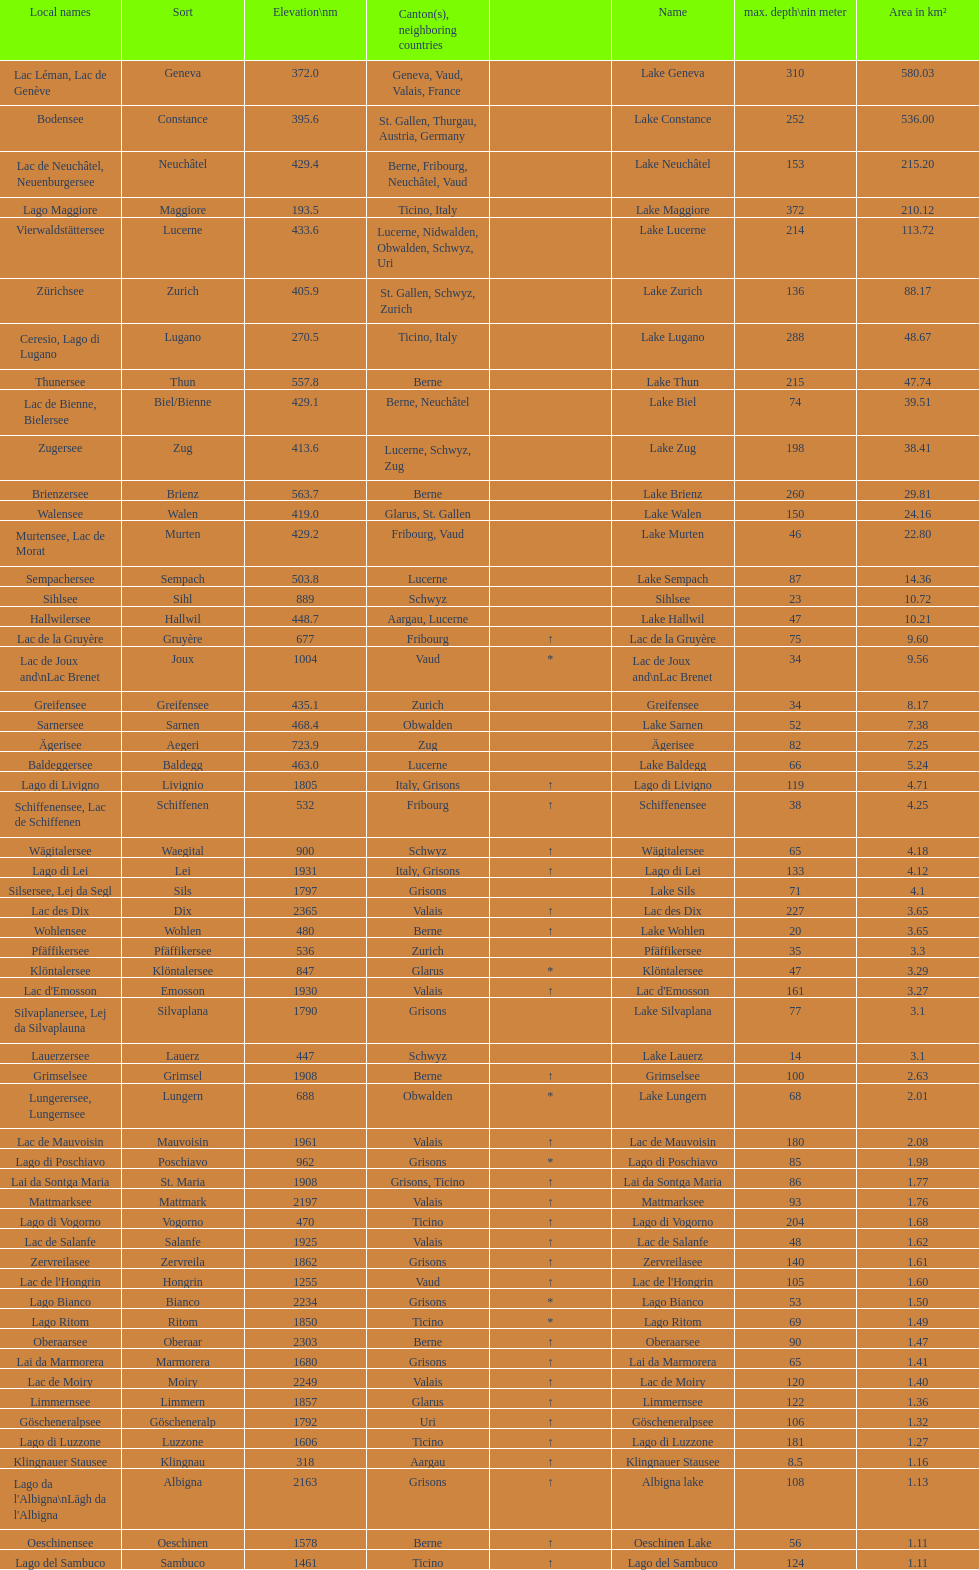What is the deepest lake? Lake Maggiore. 